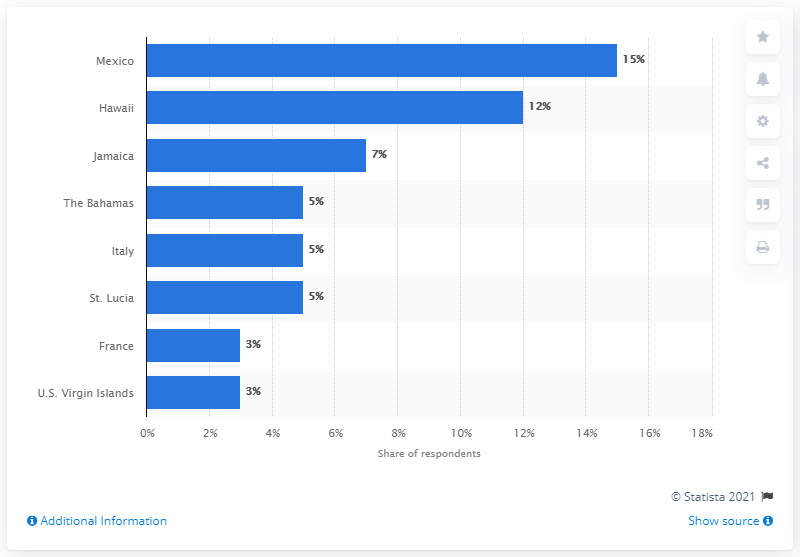What is the most popular honeymoon destination in the United States? Hawaii is the most popular honeymoon destination within the United States itself. According to the image, which appears to be a bar chart from Statista, it shows that Hawaii is the second most popular destination after Mexico, with 12% of respondents choosing it as their honeymoon destination. However, since Mexico is not part of the United States, Hawaii takes the top spot among destinations within the U.S. 